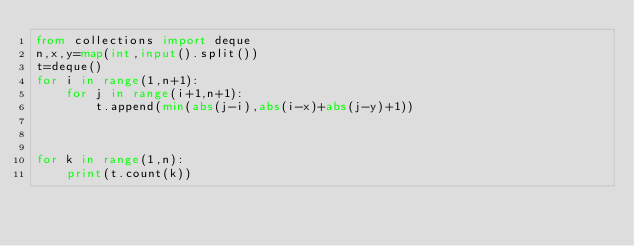<code> <loc_0><loc_0><loc_500><loc_500><_Python_>from collections import deque
n,x,y=map(int,input().split())
t=deque()
for i in range(1,n+1):
    for j in range(i+1,n+1):
        t.append(min(abs(j-i),abs(i-x)+abs(j-y)+1))



for k in range(1,n):
    print(t.count(k))</code> 